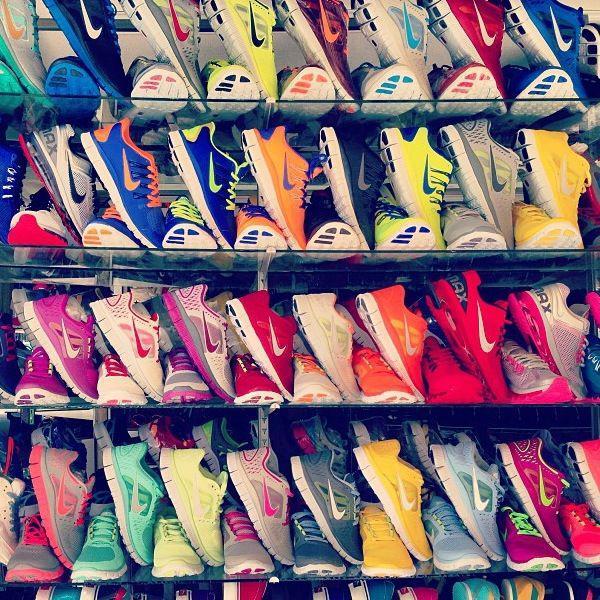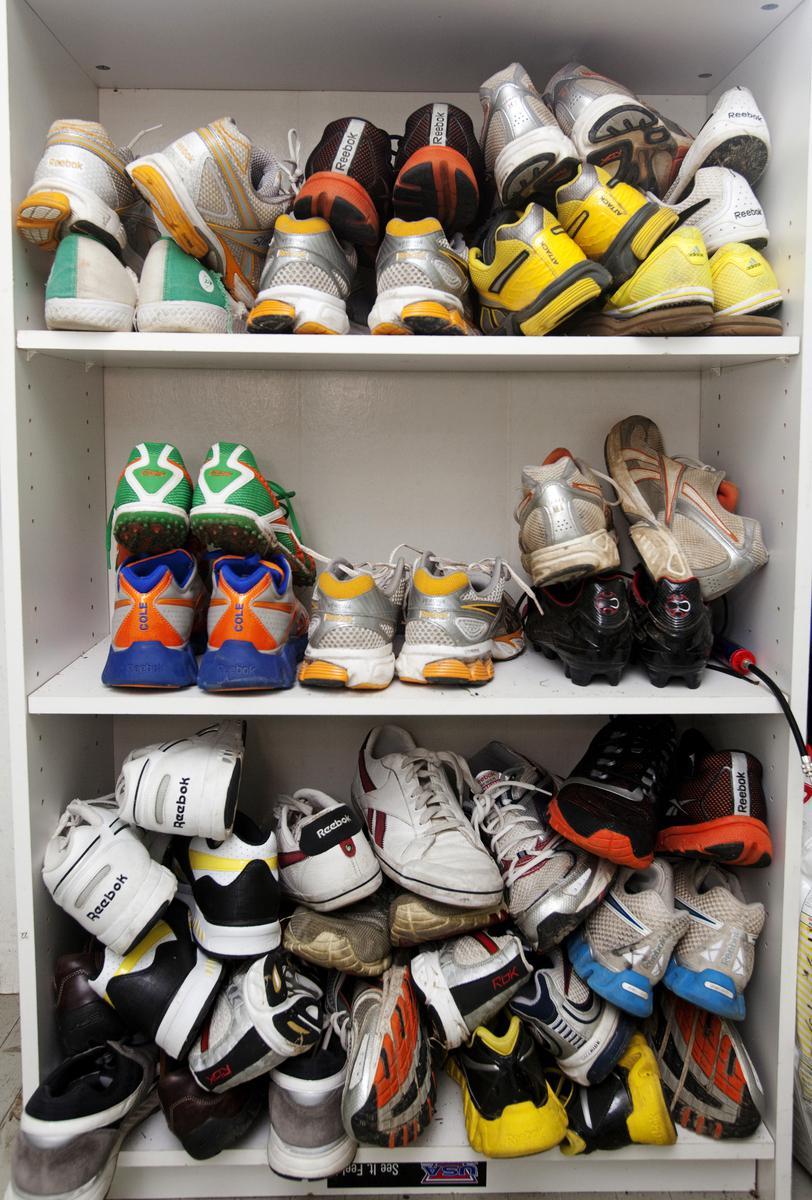The first image is the image on the left, the second image is the image on the right. For the images shown, is this caption "The shoes are arranged neatly on shelves in one of the iamges." true? Answer yes or no. Yes. 